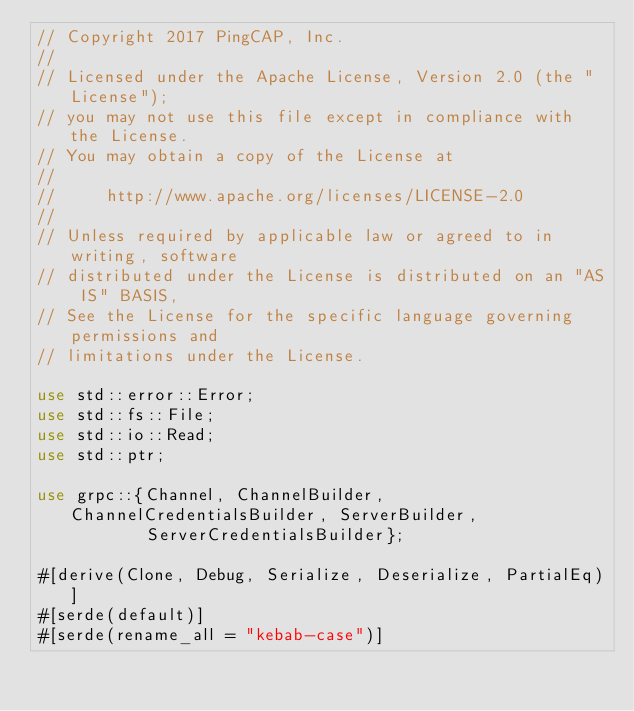Convert code to text. <code><loc_0><loc_0><loc_500><loc_500><_Rust_>// Copyright 2017 PingCAP, Inc.
//
// Licensed under the Apache License, Version 2.0 (the "License");
// you may not use this file except in compliance with the License.
// You may obtain a copy of the License at
//
//     http://www.apache.org/licenses/LICENSE-2.0
//
// Unless required by applicable law or agreed to in writing, software
// distributed under the License is distributed on an "AS IS" BASIS,
// See the License for the specific language governing permissions and
// limitations under the License.

use std::error::Error;
use std::fs::File;
use std::io::Read;
use std::ptr;

use grpc::{Channel, ChannelBuilder, ChannelCredentialsBuilder, ServerBuilder,
           ServerCredentialsBuilder};

#[derive(Clone, Debug, Serialize, Deserialize, PartialEq)]
#[serde(default)]
#[serde(rename_all = "kebab-case")]</code> 